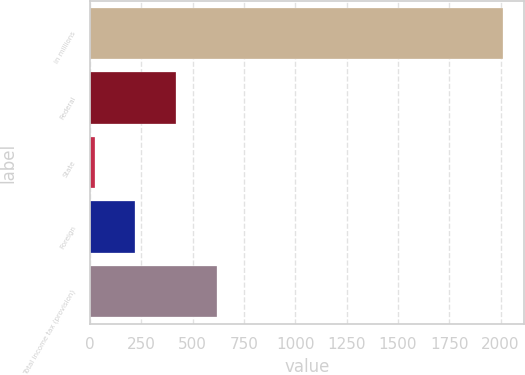Convert chart to OTSL. <chart><loc_0><loc_0><loc_500><loc_500><bar_chart><fcel>in millions<fcel>Federal<fcel>State<fcel>Foreign<fcel>Total income tax (provision)<nl><fcel>2013<fcel>420.2<fcel>22<fcel>221.1<fcel>619.3<nl></chart> 